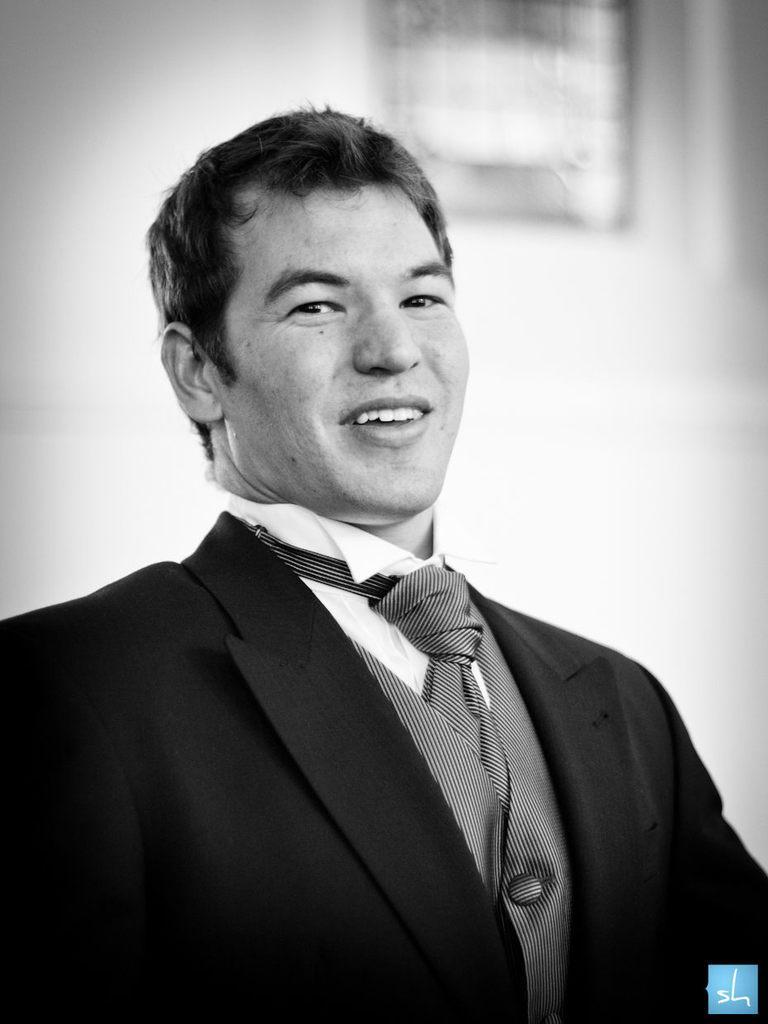Could you give a brief overview of what you see in this image? In this picture we can see a man wore a blazer, tie and smiling and in the background it is blurry. 